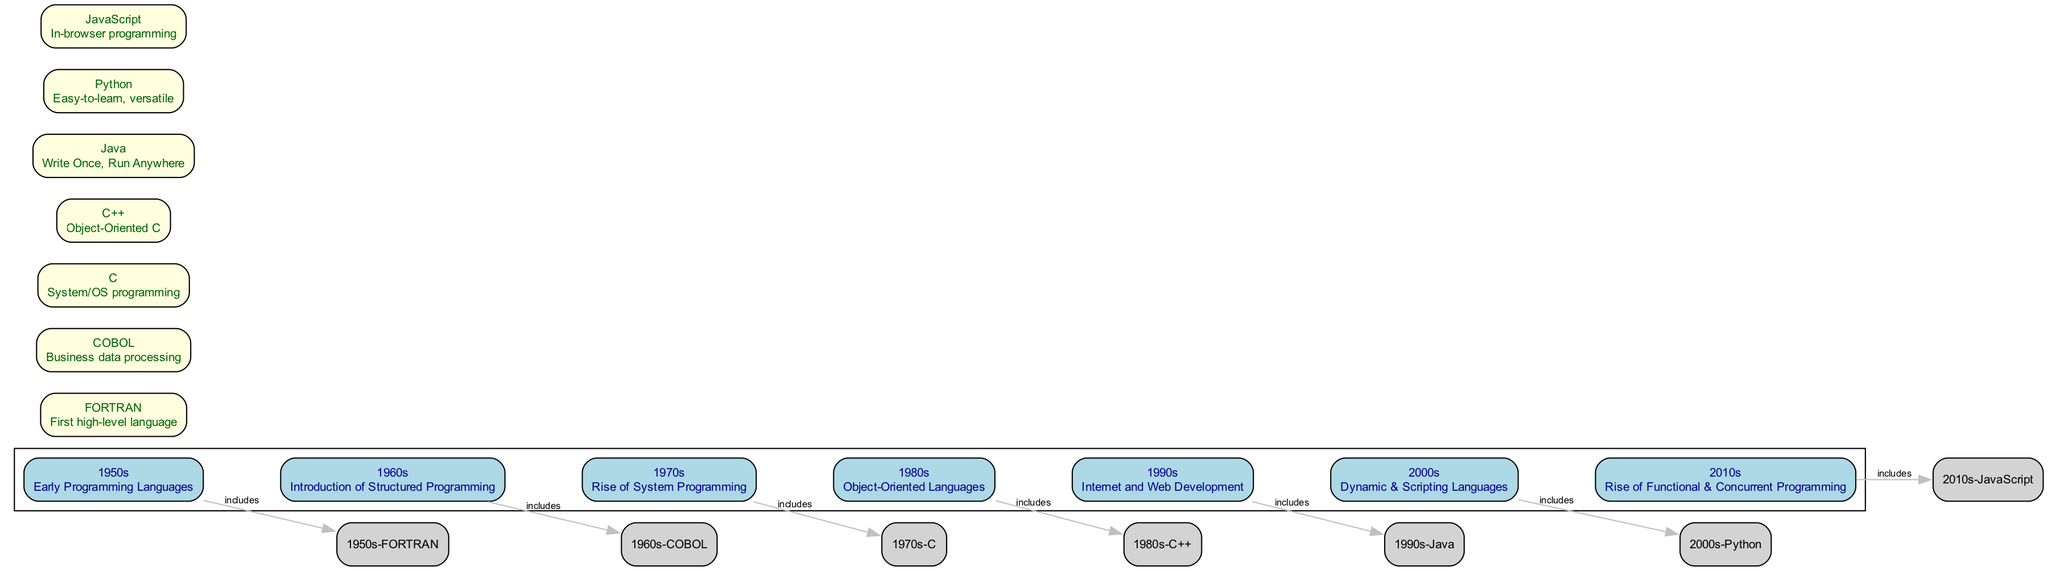What decade is represented with the introduction of structured programming? The 1960s node describes the introduction of structured programming as a key concept during that decade.
Answer: 1960s How many key programming languages are listed in the diagram? By counting the nodes that represent distinct programming languages, we find that there are seven key languages (FORTRAN, COBOL, C, C++, Java, Python, and JavaScript).
Answer: 7 What is the key feature of the programming language Java mentioned in the diagram? The description for the Java node states "Write Once, Run Anywhere", indicating its platform independence as a major feature.
Answer: Write Once, Run Anywhere Which programming language is identified for system/OS programming in the 1970s? Looking at the 1970s node, it lists C as the programming language associated with system/OS development during that decade.
Answer: C In which decade did the rise of functional and concurrent programming occur? The 2010s node indicates that this decade saw the rise of functional and concurrent programming as a notable trend in programming languages.
Answer: 2010s What relationship does the edge between 1990s and Java represent? The edge labeled "includes" signifies that the Java programming language is a representation of developments in the 1990s, connecting these two nodes.
Answer: includes Which language is known for being easy-to-learn and versatile, as per its description in the diagram? The node representing Python explicitly describes it as "Easy-to-learn, versatile", highlighting its key feature.
Answer: Python What decade corresponds to the use of object-oriented languages? According to the diagram, the 1980s node highlights the emergence of object-oriented languages during that timeframe.
Answer: 1980s How does the programming language COBOL relate to business data processing? The COBOL node directly states that it is designed for "Business data processing", establishing its role in that area.
Answer: Business data processing 